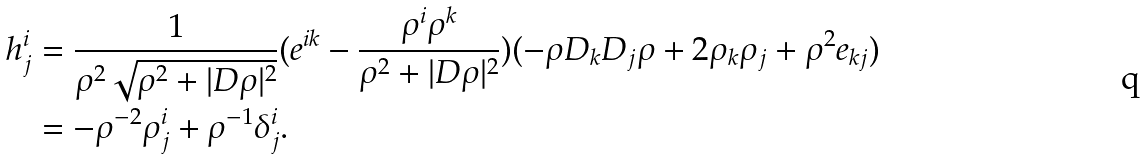Convert formula to latex. <formula><loc_0><loc_0><loc_500><loc_500>h ^ { i } _ { j } & = \frac { 1 } { \rho ^ { 2 } \sqrt { \rho ^ { 2 } + | D \rho | ^ { 2 } } } ( e ^ { i k } - \frac { \rho ^ { i } \rho ^ { k } } { \rho ^ { 2 } + | D \rho | ^ { 2 } } ) ( - \rho D _ { k } D _ { j } \rho + 2 \rho _ { k } \rho _ { j } + \rho ^ { 2 } e _ { k j } ) \\ & = - \rho ^ { - 2 } \rho ^ { i } _ { j } + \rho ^ { - 1 } \delta ^ { i } _ { j } .</formula> 